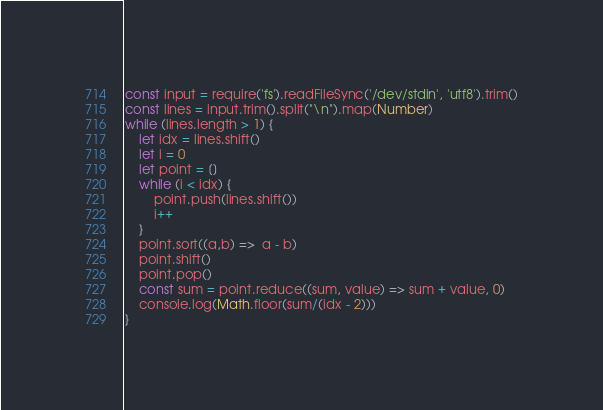<code> <loc_0><loc_0><loc_500><loc_500><_JavaScript_>const input = require('fs').readFileSync('/dev/stdin', 'utf8').trim()
const lines = input.trim().split("\n").map(Number)
while (lines.length > 1) {
    let idx = lines.shift()
    let i = 0
    let point = []
    while (i < idx) {
        point.push(lines.shift())
        i++
    }
    point.sort((a,b) =>  a - b)
    point.shift()
    point.pop()
    const sum = point.reduce((sum, value) => sum + value, 0)
    console.log(Math.floor(sum/(idx - 2)))
}
</code> 